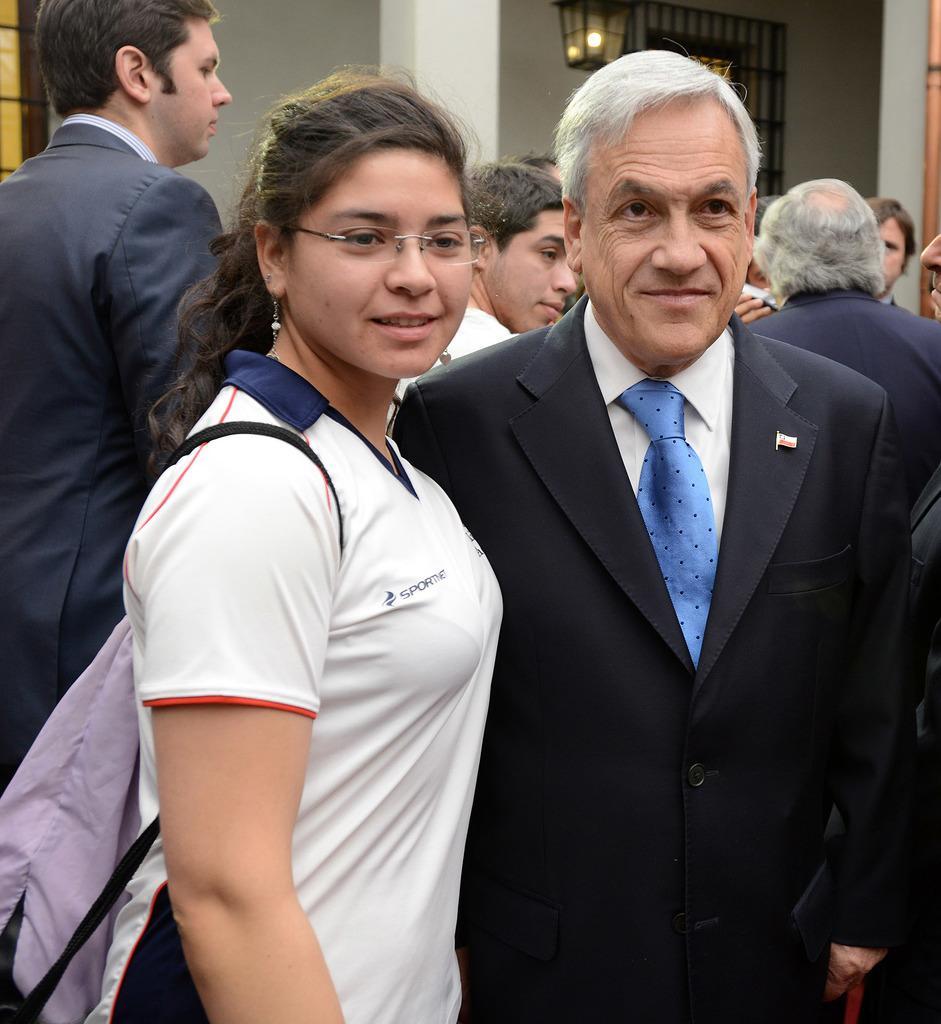How would you summarize this image in a sentence or two? In this image in the foreground there are two persons who are standing, and in the background there are a group of people and a house, light and a wall. 